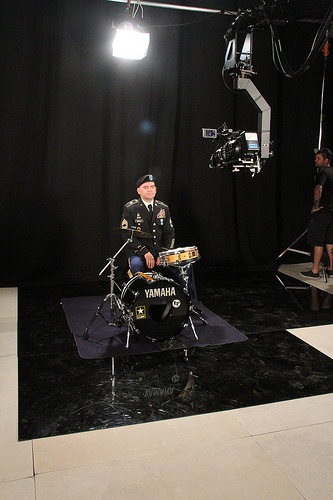<image>
Can you confirm if the skin is on the drum? Yes. Looking at the image, I can see the skin is positioned on top of the drum, with the drum providing support. Where is the man in relation to the drum? Is it to the left of the drum? No. The man is not to the left of the drum. From this viewpoint, they have a different horizontal relationship. 